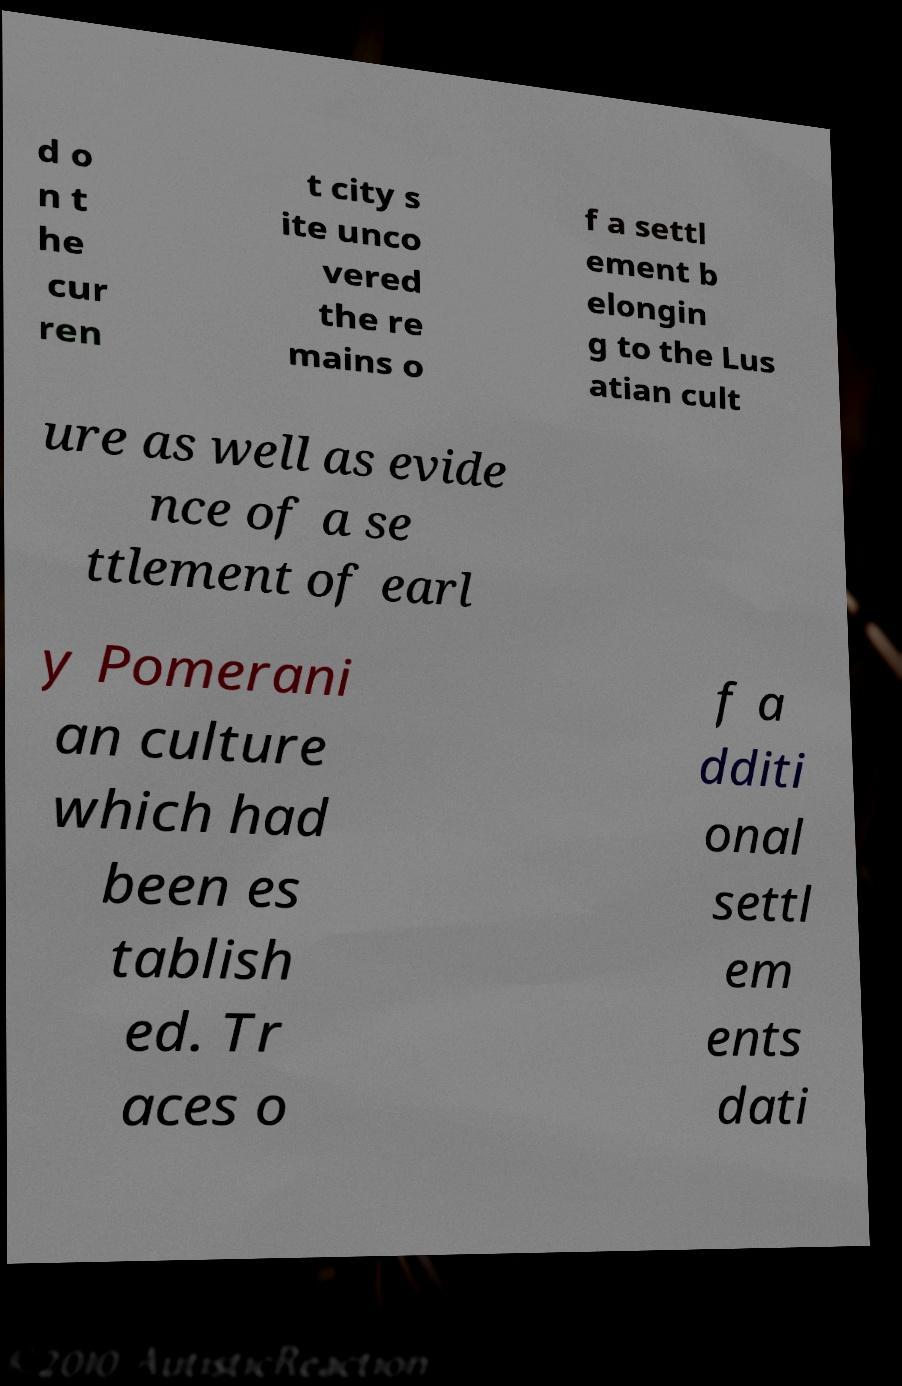Could you assist in decoding the text presented in this image and type it out clearly? d o n t he cur ren t city s ite unco vered the re mains o f a settl ement b elongin g to the Lus atian cult ure as well as evide nce of a se ttlement of earl y Pomerani an culture which had been es tablish ed. Tr aces o f a dditi onal settl em ents dati 